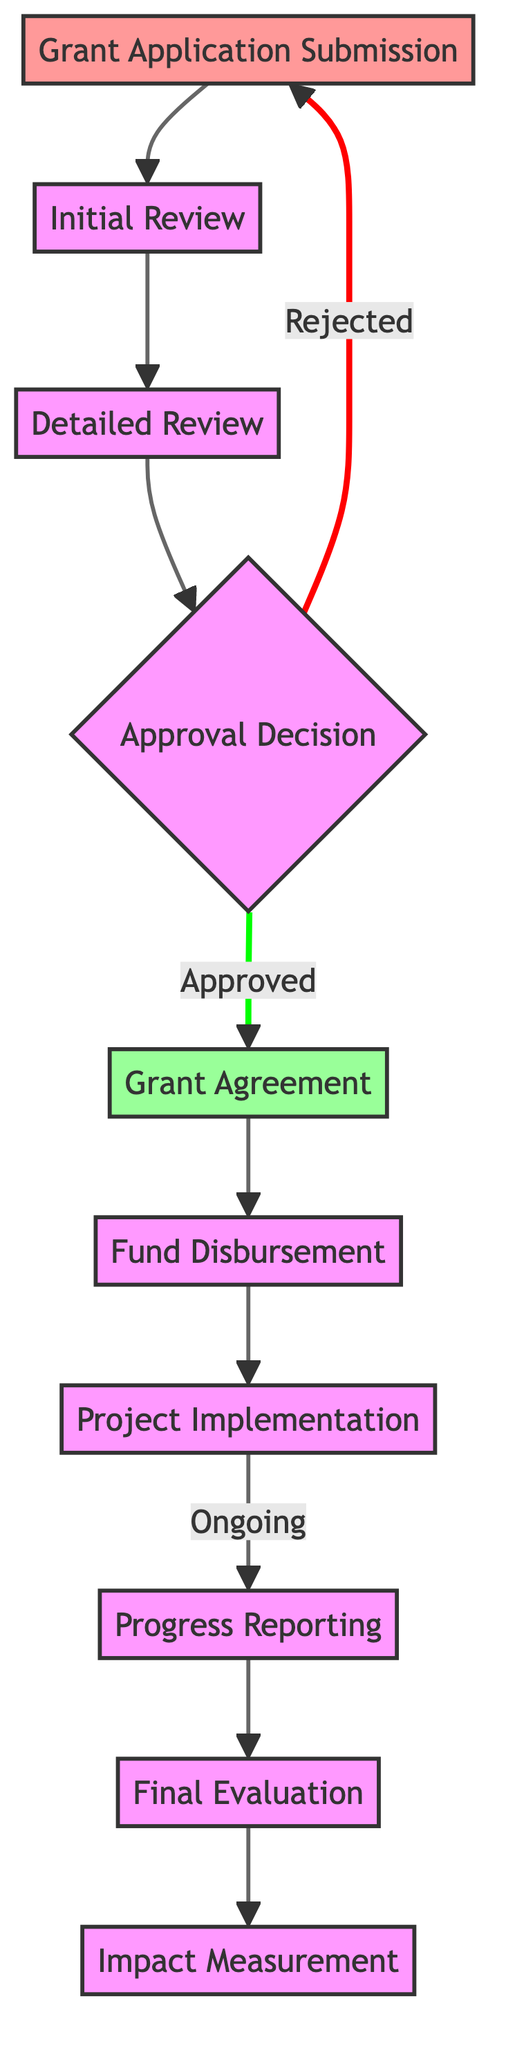What is the first step in the grant application lifecycle? The first node in the diagram is "Grant Application Submission," which indicates the starting point of the lifecycle.
Answer: Grant Application Submission How many total nodes are present in the diagram? By counting each unique process or decision point in the diagram, we find that there are ten nodes.
Answer: 10 What node follows the "Initial Review"? The edge connects "Initial Review" to "Detailed Review," showing that the next step occurs after the initial assessment.
Answer: Detailed Review What happens if the grant application is rejected? The "Rejected" edge from "Approval Decision" points back to "Grant Application Submission," indicating that the lifecycle returns to the submission stage.
Answer: Grant Application Submission What is the final step in the grant application lifecycle? The diagram concludes with an edge from "Final Evaluation" to "Impact Measurement," marking the last part of the process.
Answer: Impact Measurement Is there a node that indicates "Fund Disbursement" follows "Grant Agreement"? The edge directly connects "Grant Agreement" to "Fund Disbursement," confirming this sequential relationship.
Answer: Yes What label is associated with the edge leading to "Grant Agreement"? The edge connecting "Approval Decision" to "Grant Agreement" is labeled "Approved," indicating the condition under which the agreement is made.
Answer: Approved Which node indicates ongoing progress reporting? The edge from "Implementation" to "Progress Reporting" is labeled "Ongoing," suggesting that the reporting is a continuous process during project execution.
Answer: Progress Reporting What is the unique character of the directed graph based on the nodes' connections? The directed nature allows flow from one step to another in a linear fashion, which means each process must be completed before moving to the next.
Answer: Directed Flow 